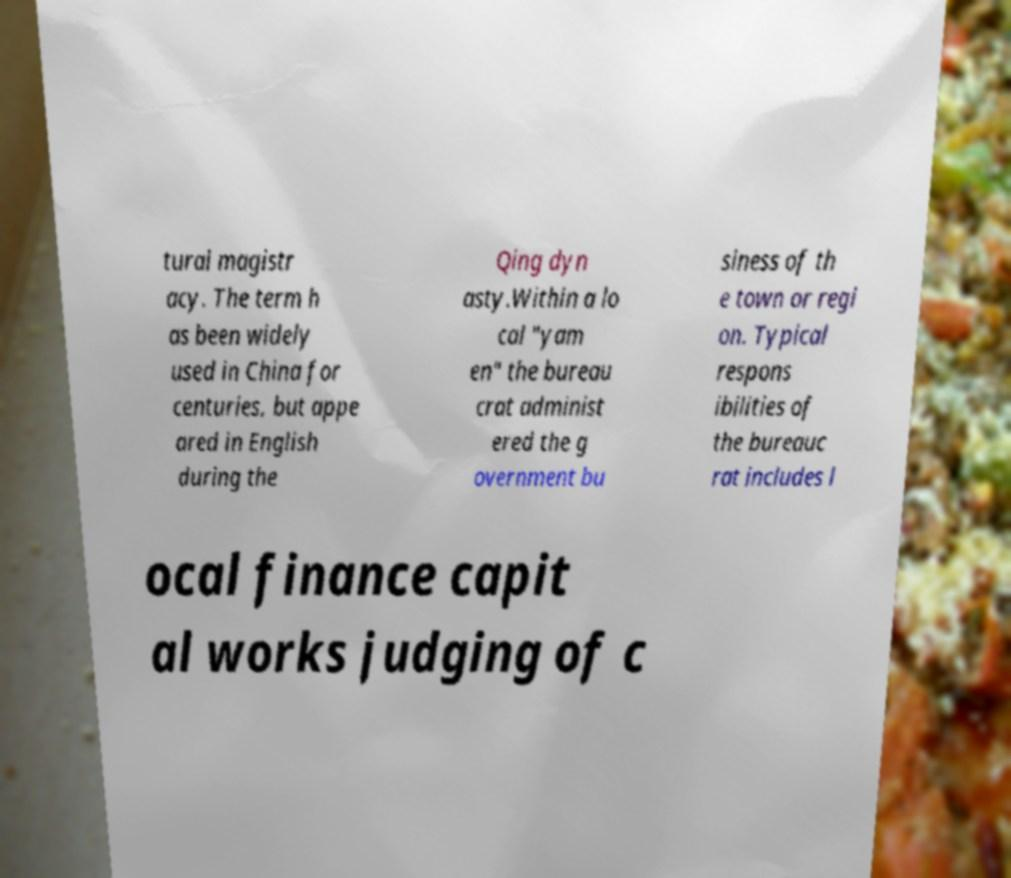Could you assist in decoding the text presented in this image and type it out clearly? tural magistr acy. The term h as been widely used in China for centuries, but appe ared in English during the Qing dyn asty.Within a lo cal "yam en" the bureau crat administ ered the g overnment bu siness of th e town or regi on. Typical respons ibilities of the bureauc rat includes l ocal finance capit al works judging of c 